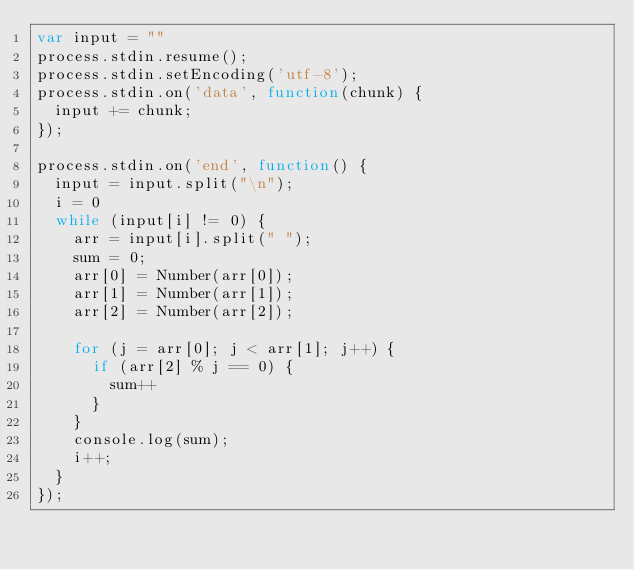<code> <loc_0><loc_0><loc_500><loc_500><_JavaScript_>var input = ""
process.stdin.resume();
process.stdin.setEncoding('utf-8');
process.stdin.on('data', function(chunk) {
  input += chunk;
});

process.stdin.on('end', function() {
  input = input.split("\n");
  i = 0
  while (input[i] != 0) {
    arr = input[i].split(" ");
    sum = 0;
    arr[0] = Number(arr[0]);
    arr[1] = Number(arr[1]);
    arr[2] = Number(arr[2]);

    for (j = arr[0]; j < arr[1]; j++) {
      if (arr[2] % j == 0) {
        sum++
      }
    }
    console.log(sum);
    i++;
  }
});</code> 